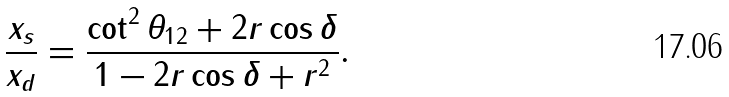<formula> <loc_0><loc_0><loc_500><loc_500>\frac { x _ { s } } { x _ { d } } = \frac { \cot ^ { 2 } \theta _ { 1 2 } + 2 r \cos \delta } { 1 - 2 r \cos \delta + r ^ { 2 } } .</formula> 